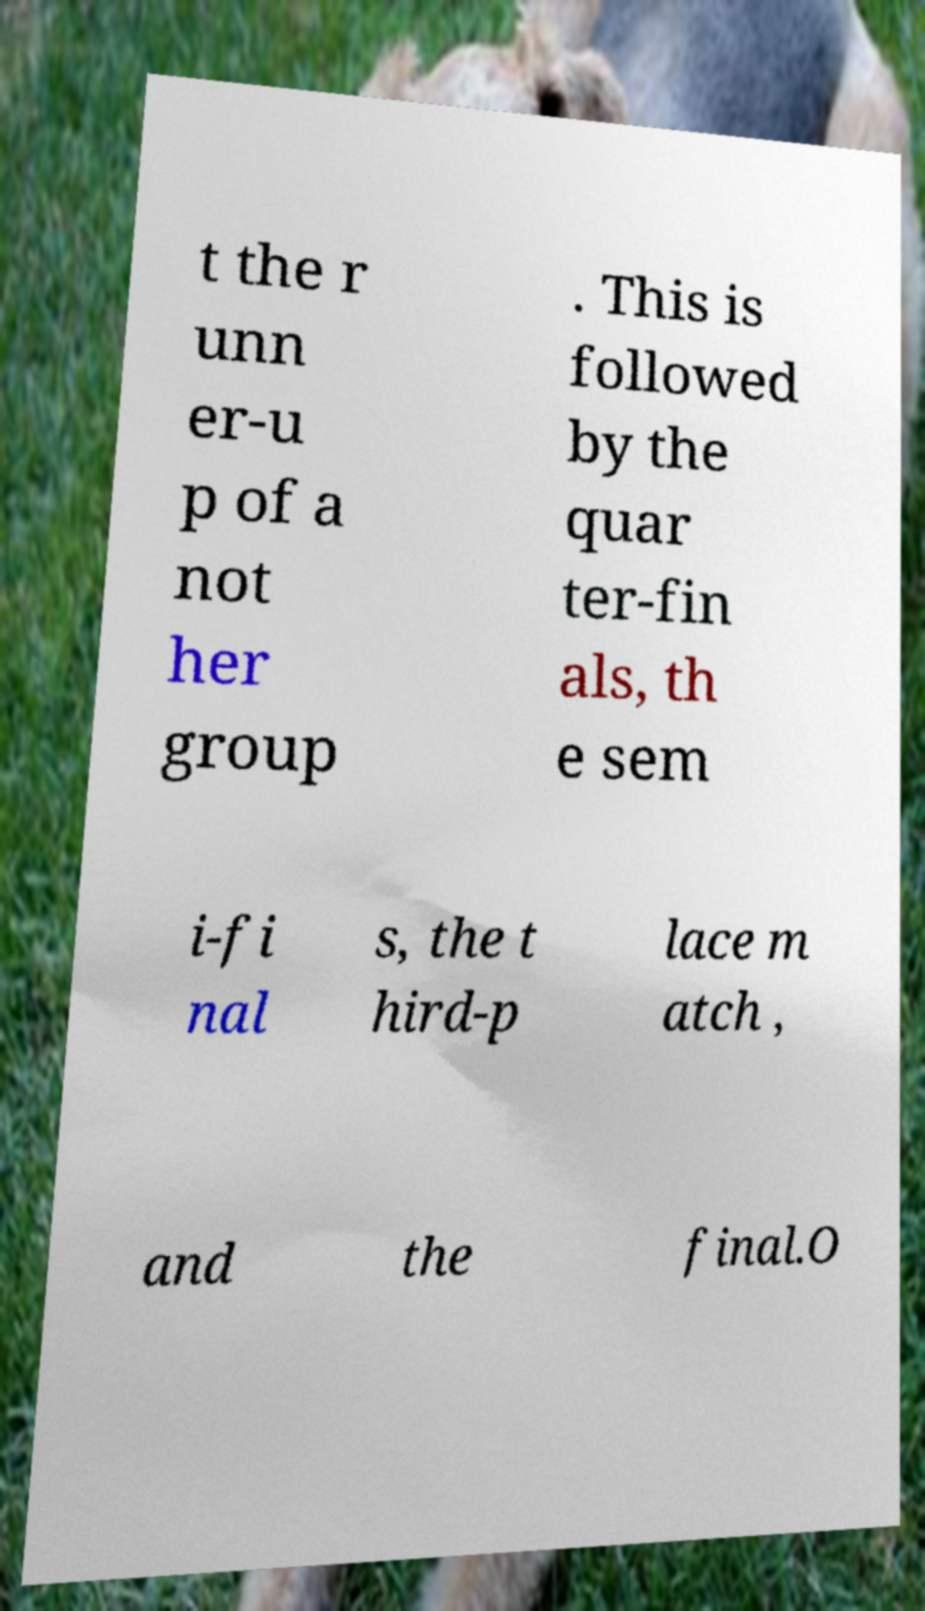Can you read and provide the text displayed in the image?This photo seems to have some interesting text. Can you extract and type it out for me? t the r unn er-u p of a not her group . This is followed by the quar ter-fin als, th e sem i-fi nal s, the t hird-p lace m atch , and the final.O 